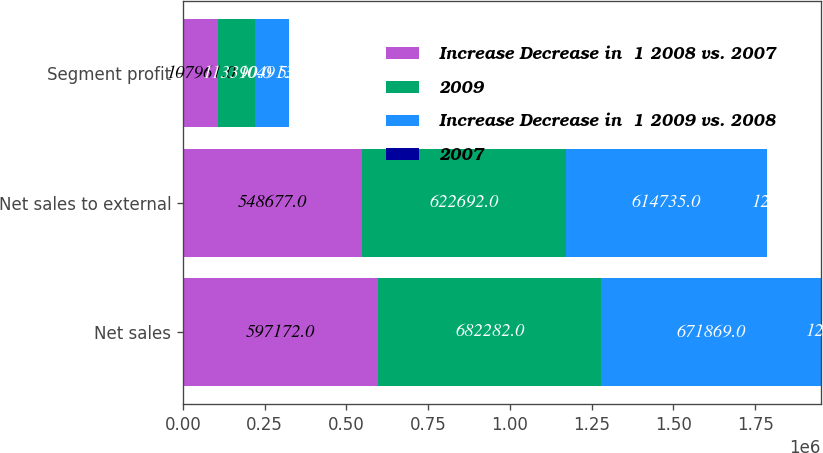Convert chart to OTSL. <chart><loc_0><loc_0><loc_500><loc_500><stacked_bar_chart><ecel><fcel>Net sales<fcel>Net sales to external<fcel>Segment profit<nl><fcel>Increase Decrease in  1 2008 vs. 2007<fcel>597172<fcel>548677<fcel>107961<nl><fcel>2009<fcel>682282<fcel>622692<fcel>113390<nl><fcel>Increase Decrease in  1 2009 vs. 2008<fcel>671869<fcel>614735<fcel>104913<nl><fcel>2007<fcel>12<fcel>12<fcel>5<nl></chart> 